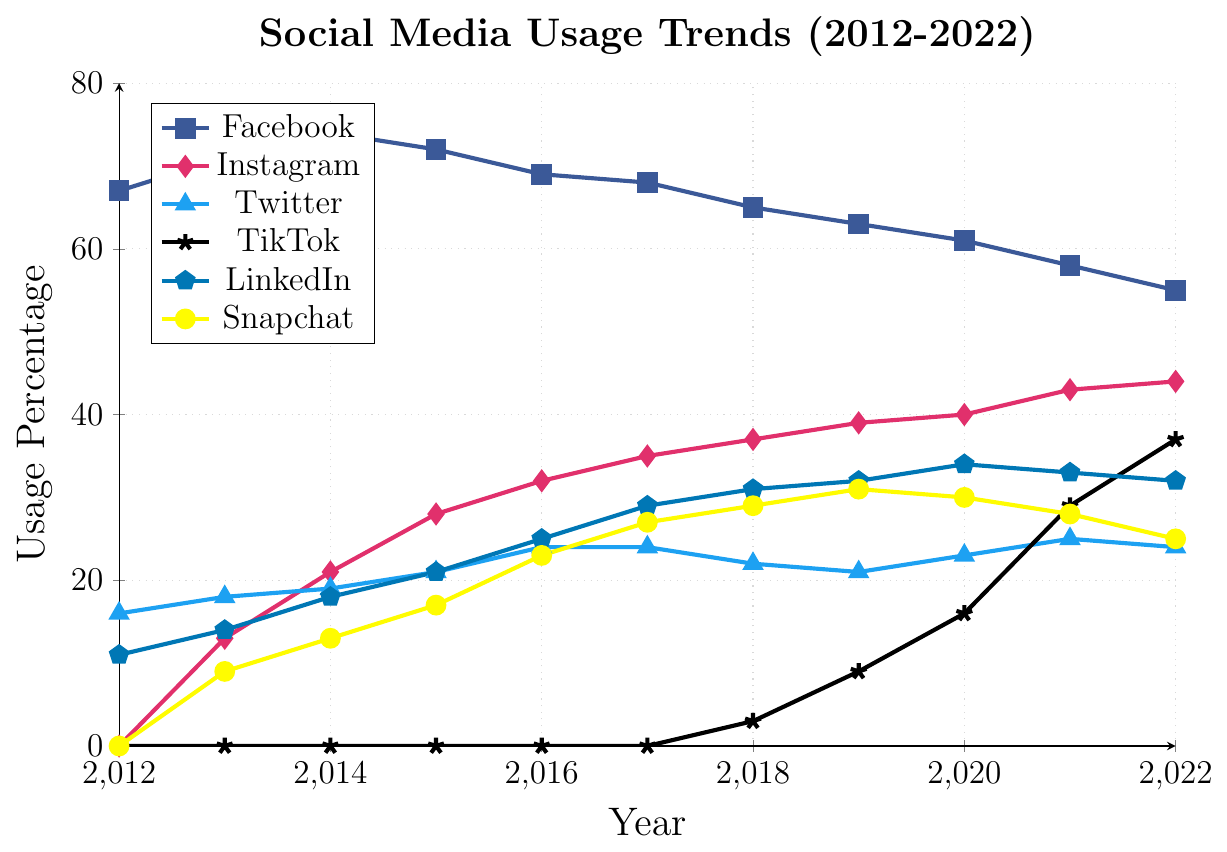How has Facebook's usage percentage changed from 2012 to 2022? Facebook's usage percentage in 2012 was 67% and in 2022 it was 55%. The change is 67% - 55% = 12% decrease.
Answer: 12% decrease Which social media platform had the highest increase in usage percentage from 2012 to 2022? TikTok had 0% usage in 2012 and 37% in 2022, which is the highest increase among all platforms with an increase of 37%.
Answer: TikTok What was the usage percentage of Instagram in 2017 compared to Twitter in the same year? Instagram's usage percentage in 2017 was 35%, and Twitter's was 24%. Comparing both, Instagram had a higher usage in 2017.
Answer: Instagram had higher usage Which platform showed a steady increase every year from 2012 to 2022? TikTok showed a steady increase each year from 2012 (0%) to 2022 (37%) without any declines.
Answer: TikTok In which year did Snapchat peak in its usage percentage? Snapchat peaked in its usage percentage in 2019 with 31%.
Answer: 2019 Compare the usage percentage of LinkedIn and Snapchat in 2020. Which one was higher? LinkedIn's usage percentage in 2020 was 34%, while Snapchat's was 30%. LinkedIn had a higher percentage.
Answer: LinkedIn What is the average usage percentage of Facebook from 2012 to 2022? The sum of Facebook's percentages from 2012 to 2022 is 687%. There are 11 years, so the average is 687% / 11 ≈ 62.45%.
Answer: 62.45% Which platform had the greatest decrease in usage percentage between any two consecutive years, and what is the value of that decrease? Facebook had the greatest decrease between 2014 and 2015, going from 74% to 72%, a decrease of 2%.
Answer: Facebook, 2% Between 2018 and 2022, which platform had the largest increase in percentage? TikTok increased from 3% in 2018 to 37% in 2022, which is an increase of 34%.
Answer: TikTok By how much did Instagram's usage percentage increase from 2013 to 2015? Instagram's usage percentage increased from 13% in 2013 to 28% in 2015. The increase is 28% - 13% = 15%.
Answer: 15% 